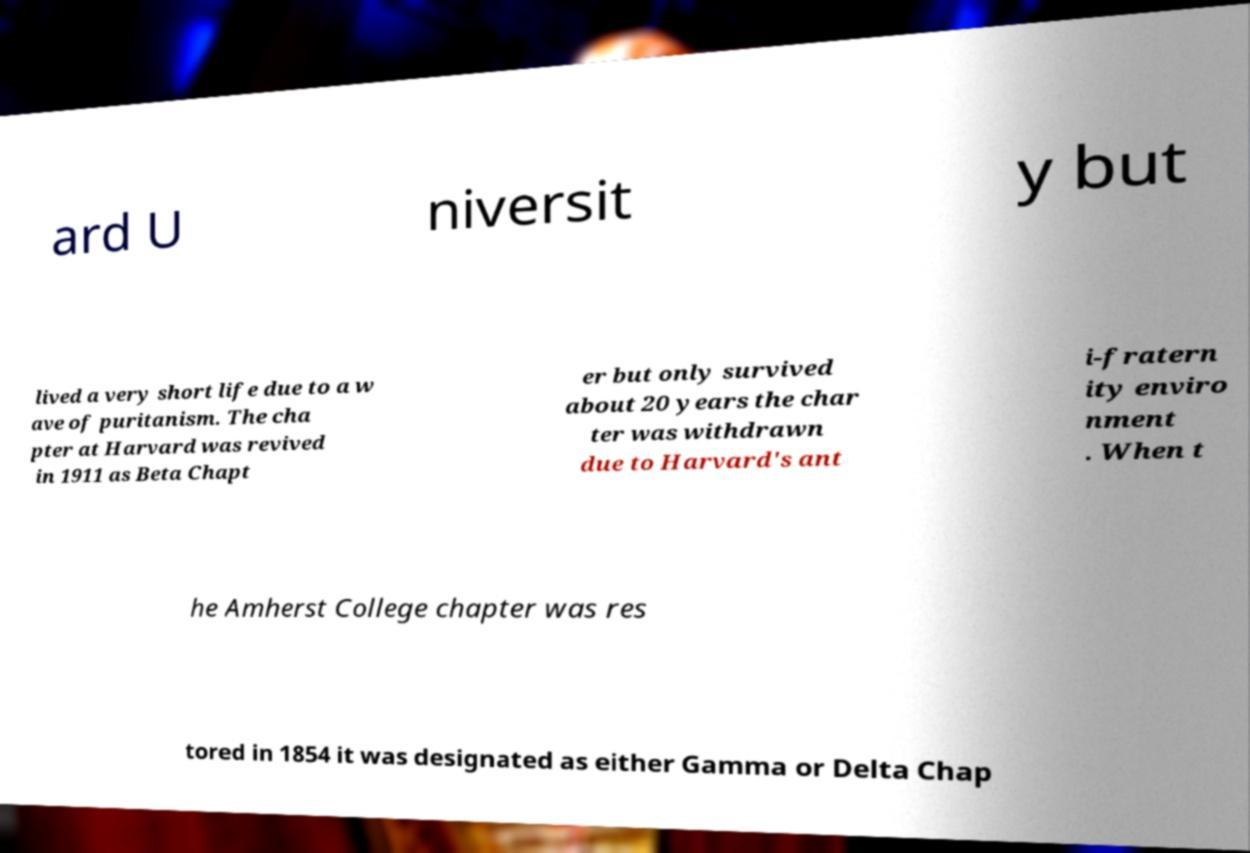What messages or text are displayed in this image? I need them in a readable, typed format. ard U niversit y but lived a very short life due to a w ave of puritanism. The cha pter at Harvard was revived in 1911 as Beta Chapt er but only survived about 20 years the char ter was withdrawn due to Harvard's ant i-fratern ity enviro nment . When t he Amherst College chapter was res tored in 1854 it was designated as either Gamma or Delta Chap 